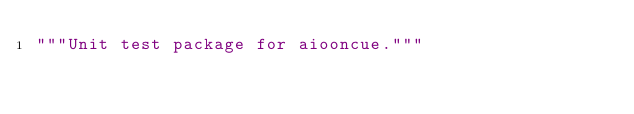Convert code to text. <code><loc_0><loc_0><loc_500><loc_500><_Python_>"""Unit test package for aiooncue."""
</code> 